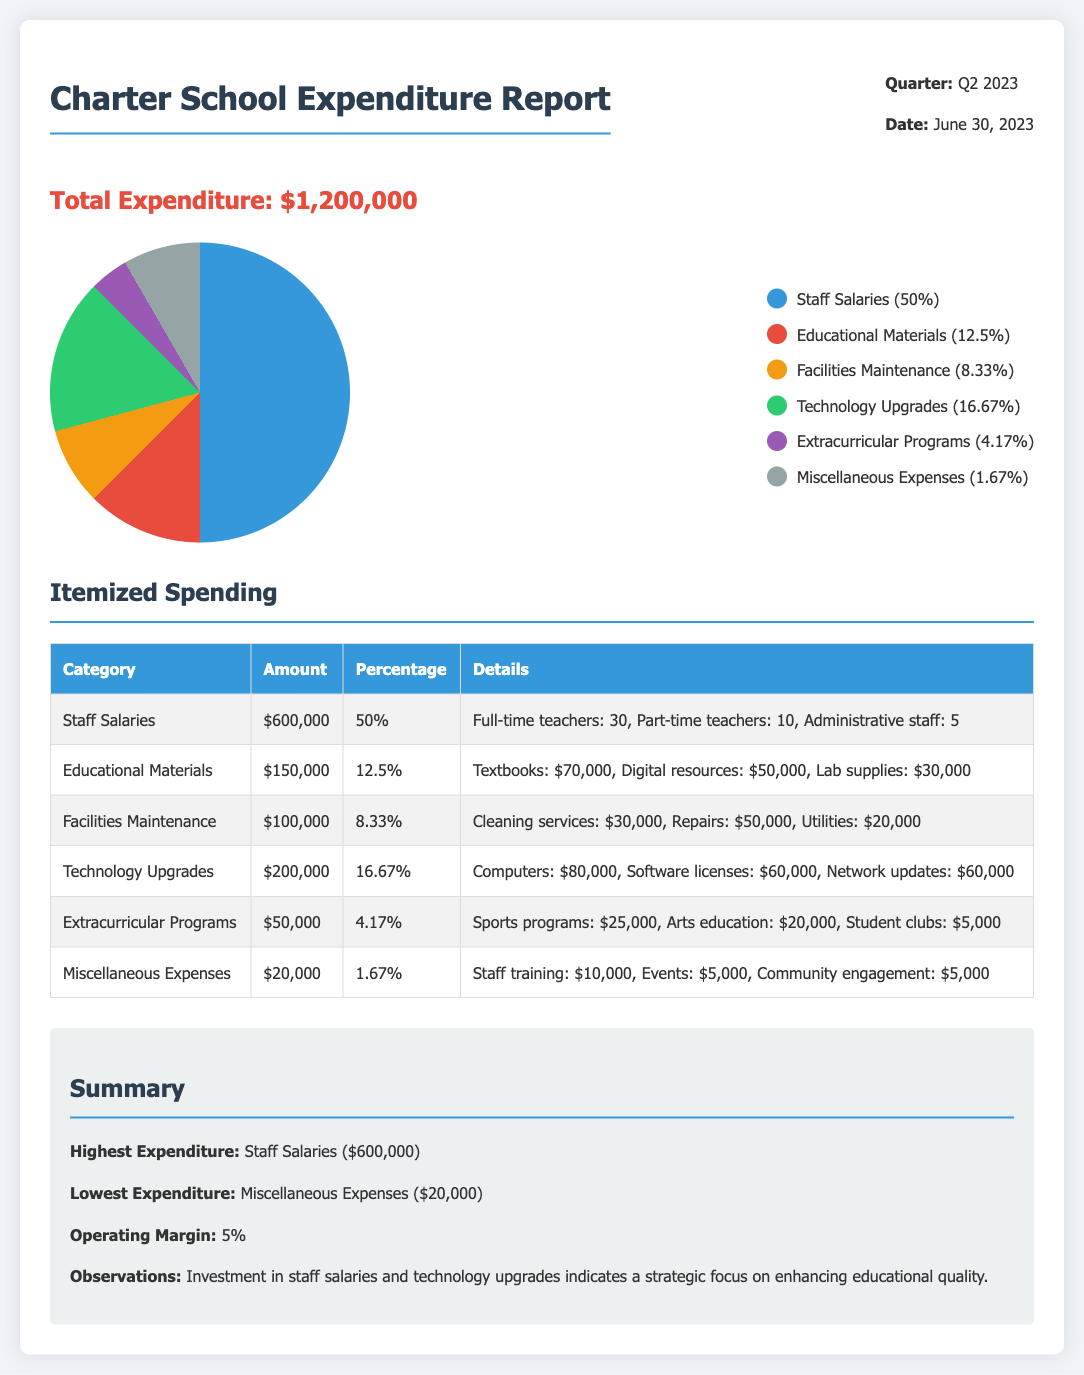What is the total expenditure for Q2 2023? The total expenditure is stated clearly in the document, which is $1,200,000.
Answer: $1,200,000 What percentage of the budget was spent on staff salaries? The document states that staff salaries accounted for 50% of the total expenditure.
Answer: 50% What amount was allocated to technology upgrades? The expenditure report specifies that $200,000 was dedicated to technology upgrades.
Answer: $200,000 Which category had the lowest expenditure? The document notes that the lowest expenditure category was miscellaneous expenses.
Answer: Miscellaneous Expenses What was the operating margin percentage? The report mentions an operating margin of 5%.
Answer: 5% How much money was spent on educational materials? According to the report, the school spent $150,000 on educational materials.
Answer: $150,000 What are the details of the staff salaries expenditures? The document provides details indicating that the staff salaries included full-time teachers, part-time teachers, and administrative staff.
Answer: Full-time teachers: 30, Part-time teachers: 10, Administrative staff: 5 What was the percentage of spending on extracurricular programs? The report indicates that 4.17% of the total expenditure went towards extracurricular programs.
Answer: 4.17% How much was spent on facilities maintenance? The expenditure for facilities maintenance is clearly listed as $100,000 in the report.
Answer: $100,000 